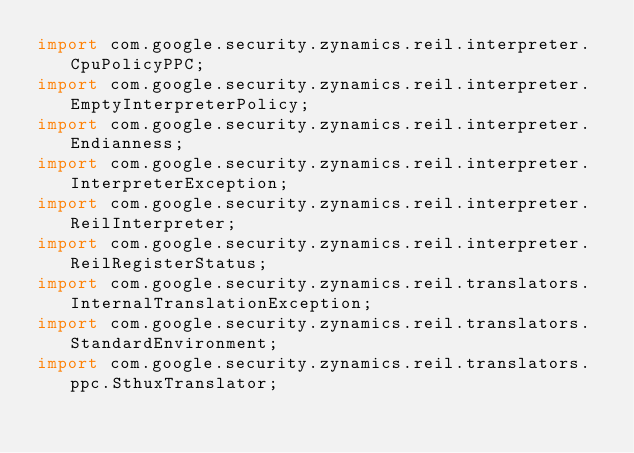<code> <loc_0><loc_0><loc_500><loc_500><_Java_>import com.google.security.zynamics.reil.interpreter.CpuPolicyPPC;
import com.google.security.zynamics.reil.interpreter.EmptyInterpreterPolicy;
import com.google.security.zynamics.reil.interpreter.Endianness;
import com.google.security.zynamics.reil.interpreter.InterpreterException;
import com.google.security.zynamics.reil.interpreter.ReilInterpreter;
import com.google.security.zynamics.reil.interpreter.ReilRegisterStatus;
import com.google.security.zynamics.reil.translators.InternalTranslationException;
import com.google.security.zynamics.reil.translators.StandardEnvironment;
import com.google.security.zynamics.reil.translators.ppc.SthuxTranslator;</code> 